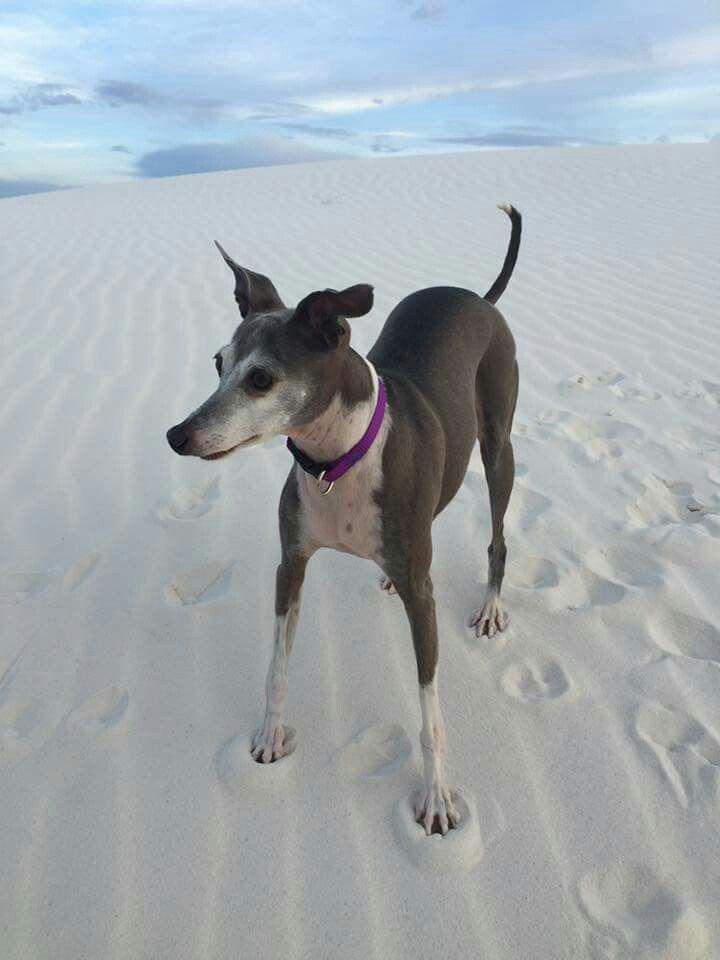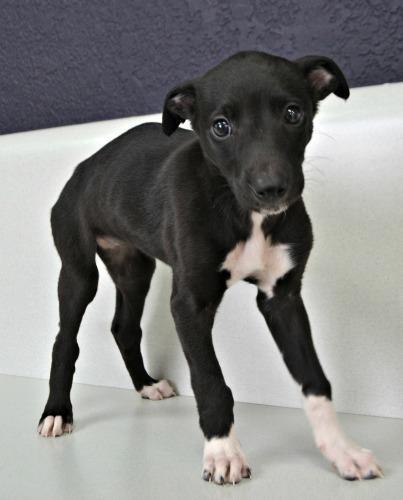The first image is the image on the left, the second image is the image on the right. For the images shown, is this caption "Each Miniature Greyhound dog is standing on all four legs." true? Answer yes or no. Yes. The first image is the image on the left, the second image is the image on the right. Given the left and right images, does the statement "An image shows a non-costumed dog with a black face and body, and white paws and chest." hold true? Answer yes or no. Yes. 